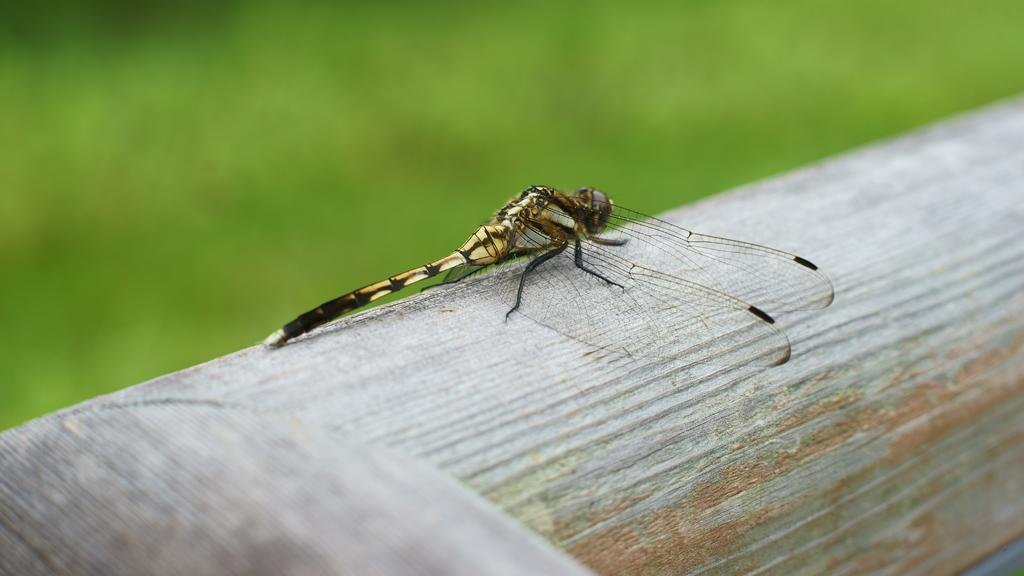What insect can be seen in the image? There is a dragonfly in the image. What surface is the dragonfly resting on? The dragonfly is on wood. Is the dragonfly holding a kite in the image? No, there is no kite present in the image. The dragonfly is simply resting on wood. 